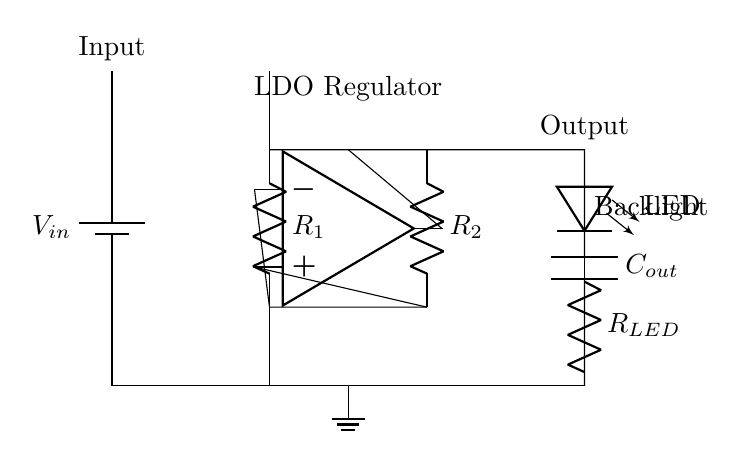What is the input component in this circuit? The input component is the battery which provides power to the circuit, identified as V in the diagram.
Answer: Battery What does the LED represent in this circuit? The LED represents the backlight for UI elements in the game interface, which illuminates when the current flows through it.
Answer: Backlight What is the function of the operational amplifier? The operational amplifier is used to compare voltages; it takes the input voltage and regulates the output voltage to maintain a consistent level through the regulator.
Answer: Regulation How many resistors are present in this circuit? There are two resistors, R1 and R2, visible connecting the operational amplifier and the LDO regulator.
Answer: Two What type of circuit is depicted here? This circuit is a low-dropout regulator circuit designed for consistent backlighting in high-contrast game UI elements.
Answer: Low-dropout regulator What is labeled on the output side of the circuit? The output side is labeled as the output, indicating where the regulated voltage is provided to the LED backlight.
Answer: Output What type of capacitor is used in this circuit? The capacitor used is an output capacitor, designated as Cout, which smooths out the voltage fluctuations at the output.
Answer: Output capacitor 